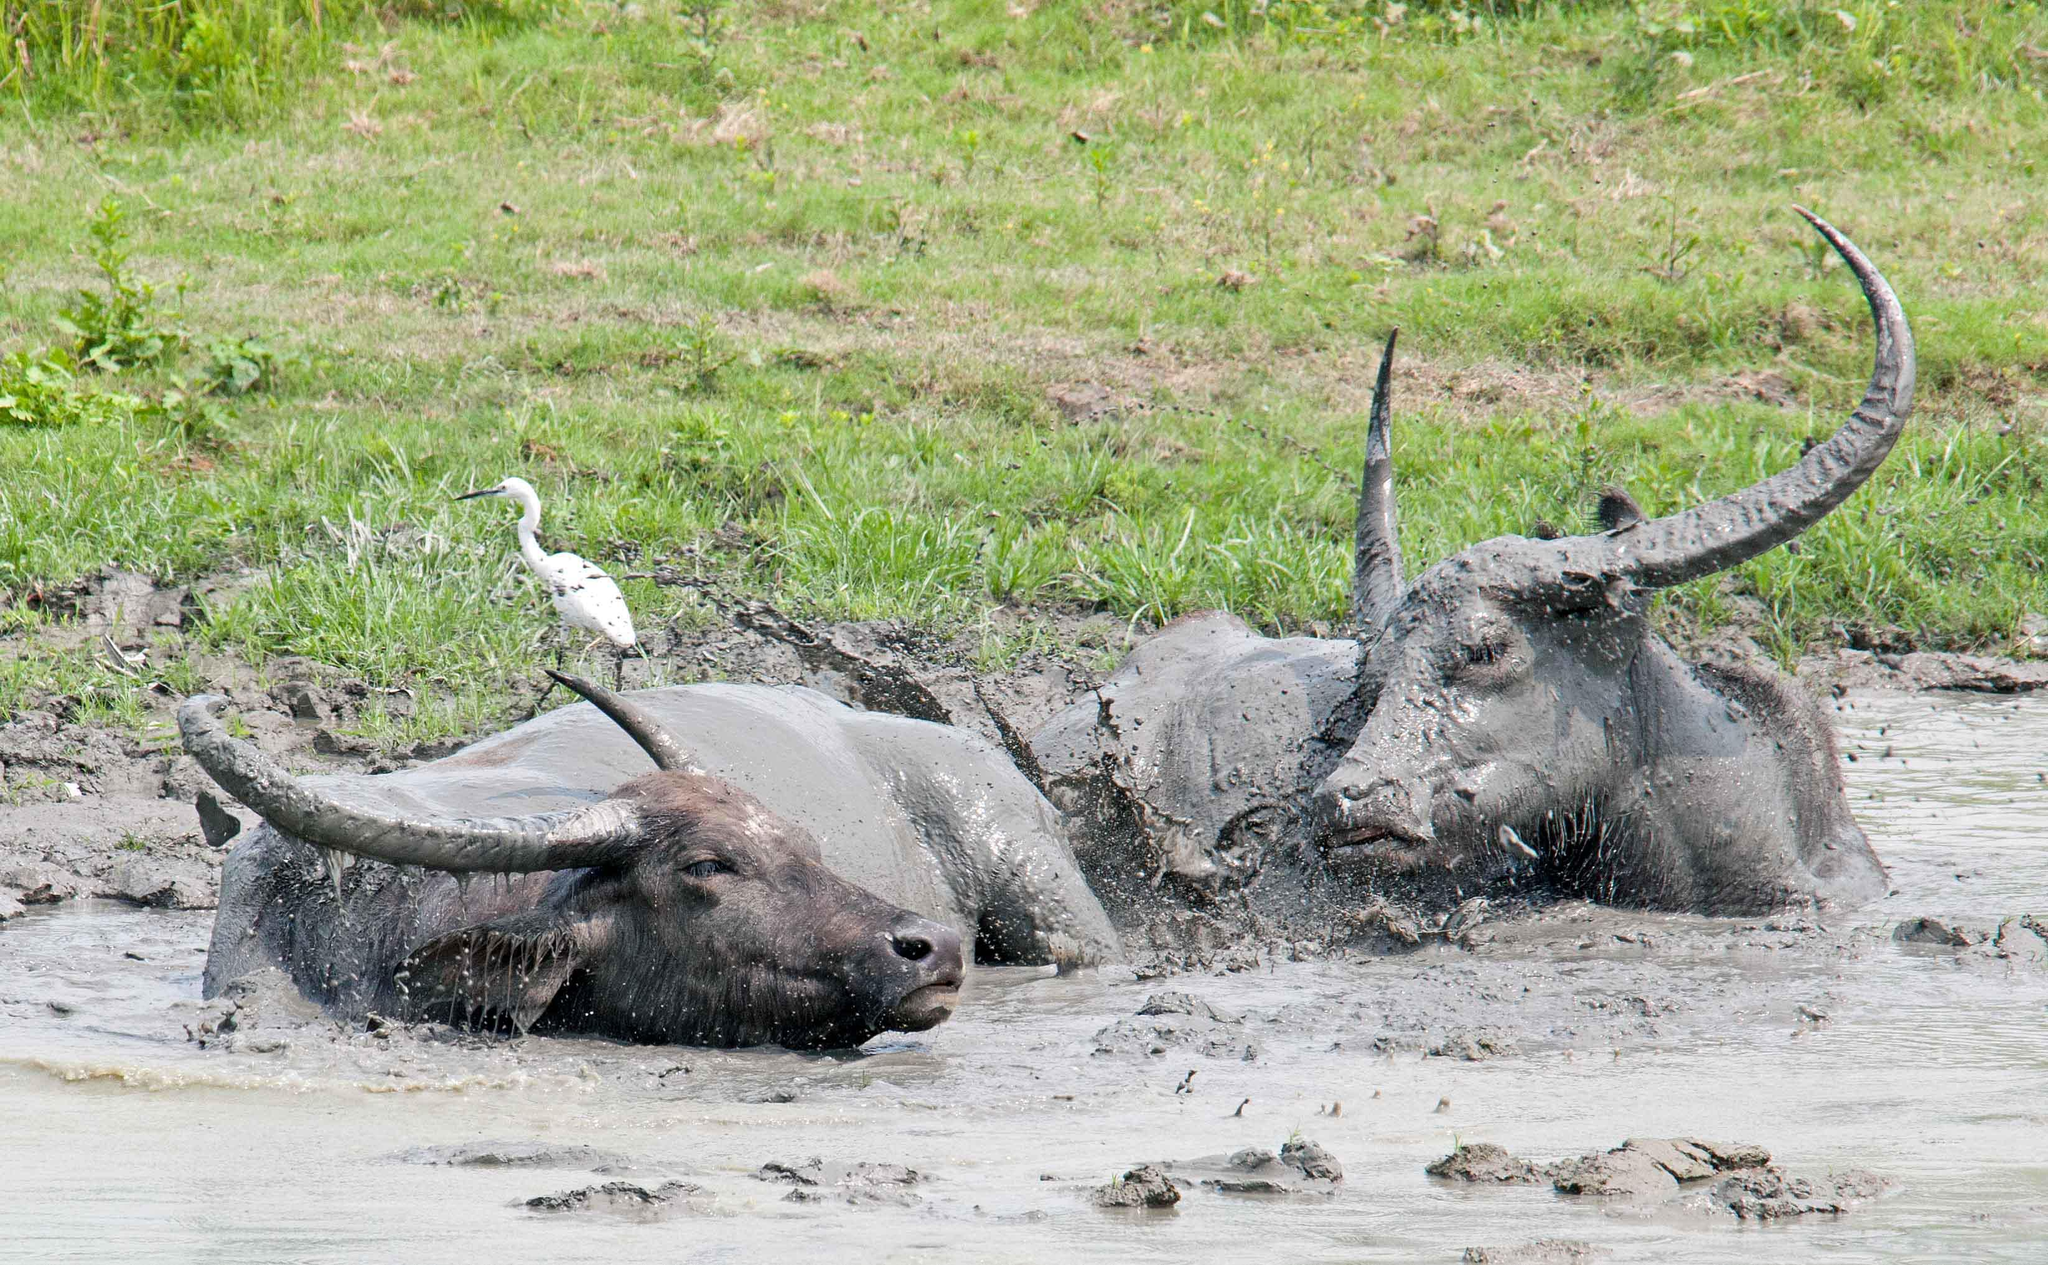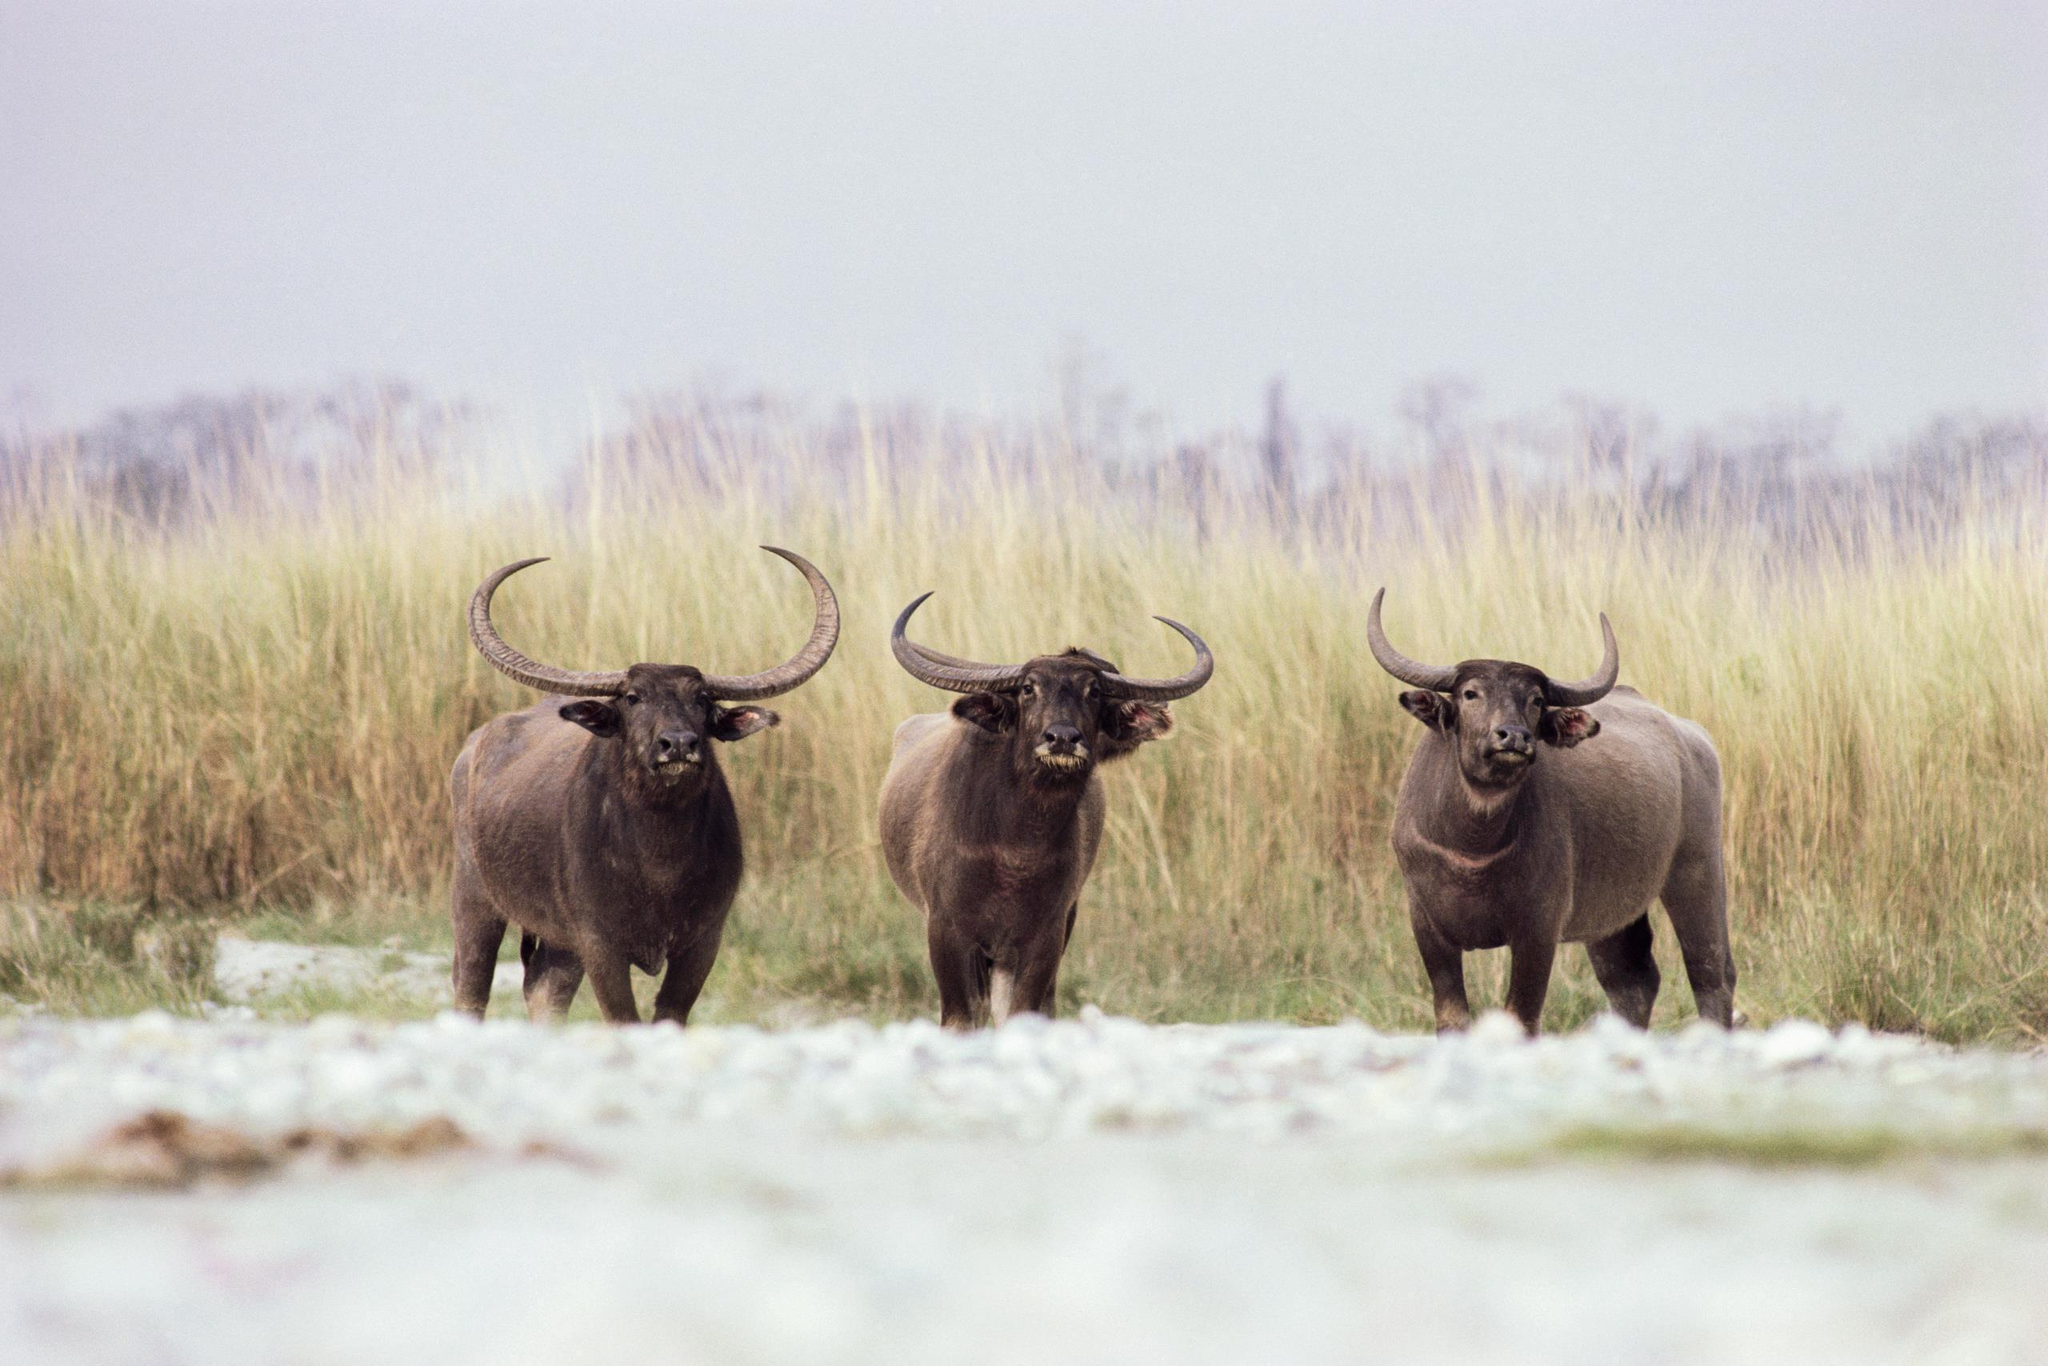The first image is the image on the left, the second image is the image on the right. Considering the images on both sides, is "The left image contains a sculpture of a water buffalo." valid? Answer yes or no. No. The first image is the image on the left, the second image is the image on the right. Given the left and right images, does the statement "The left image contains a water buffalo with a bird standing on its back." hold true? Answer yes or no. Yes. 